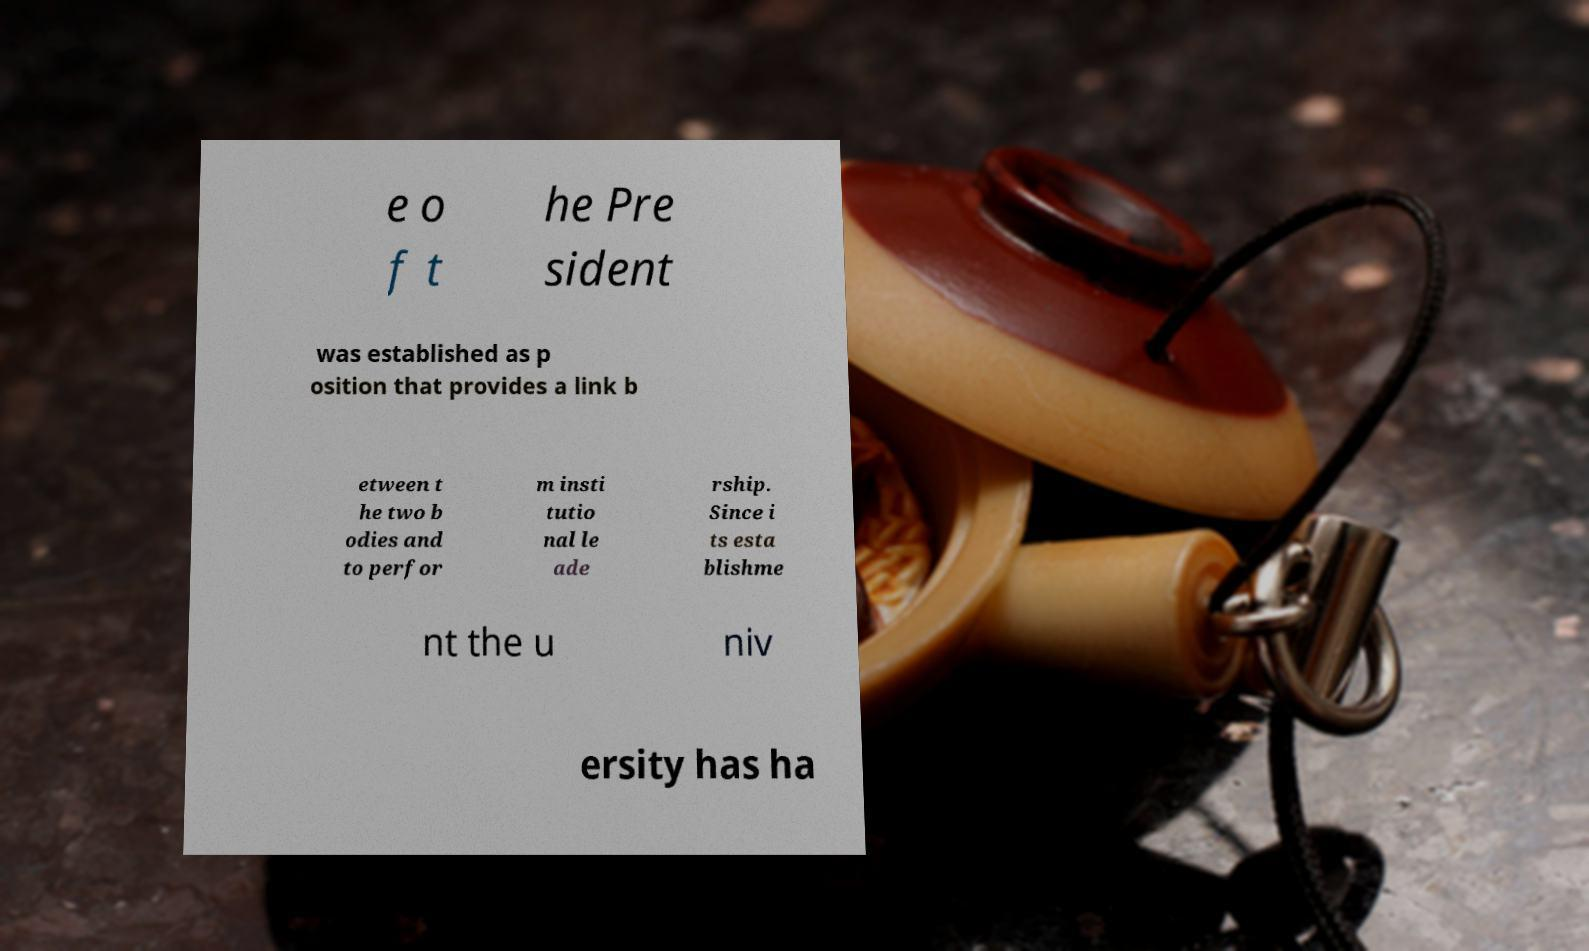Could you assist in decoding the text presented in this image and type it out clearly? e o f t he Pre sident was established as p osition that provides a link b etween t he two b odies and to perfor m insti tutio nal le ade rship. Since i ts esta blishme nt the u niv ersity has ha 